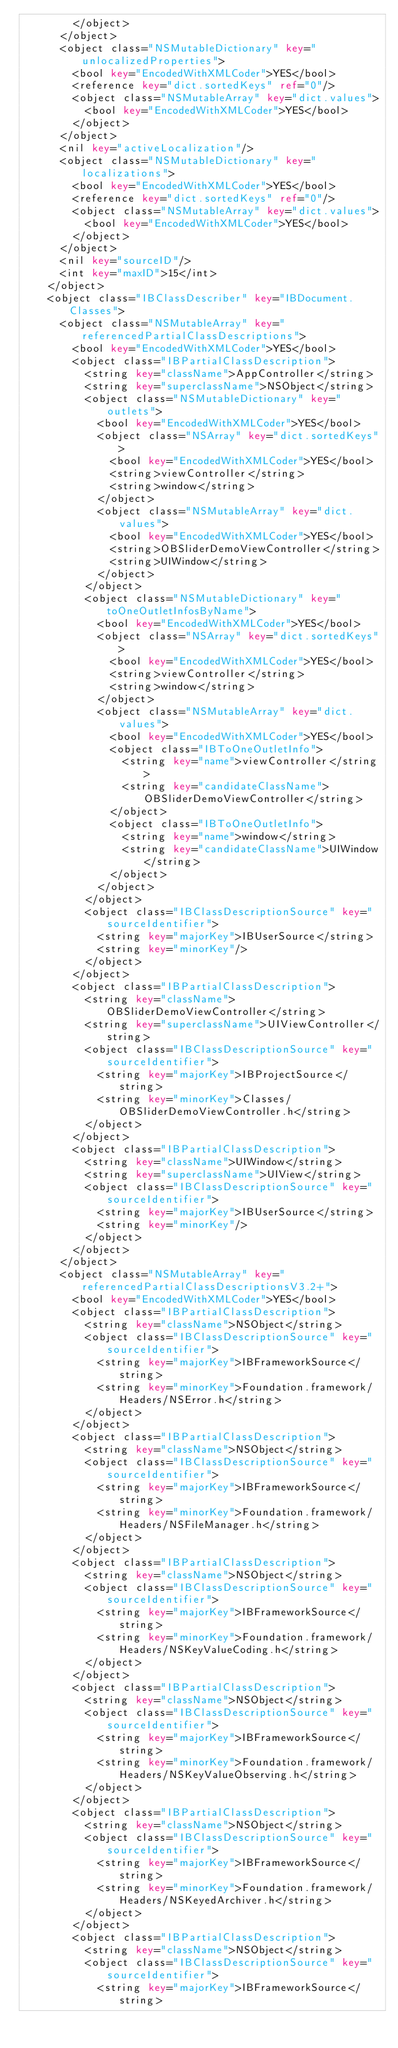Convert code to text. <code><loc_0><loc_0><loc_500><loc_500><_XML_>				</object>
			</object>
			<object class="NSMutableDictionary" key="unlocalizedProperties">
				<bool key="EncodedWithXMLCoder">YES</bool>
				<reference key="dict.sortedKeys" ref="0"/>
				<object class="NSMutableArray" key="dict.values">
					<bool key="EncodedWithXMLCoder">YES</bool>
				</object>
			</object>
			<nil key="activeLocalization"/>
			<object class="NSMutableDictionary" key="localizations">
				<bool key="EncodedWithXMLCoder">YES</bool>
				<reference key="dict.sortedKeys" ref="0"/>
				<object class="NSMutableArray" key="dict.values">
					<bool key="EncodedWithXMLCoder">YES</bool>
				</object>
			</object>
			<nil key="sourceID"/>
			<int key="maxID">15</int>
		</object>
		<object class="IBClassDescriber" key="IBDocument.Classes">
			<object class="NSMutableArray" key="referencedPartialClassDescriptions">
				<bool key="EncodedWithXMLCoder">YES</bool>
				<object class="IBPartialClassDescription">
					<string key="className">AppController</string>
					<string key="superclassName">NSObject</string>
					<object class="NSMutableDictionary" key="outlets">
						<bool key="EncodedWithXMLCoder">YES</bool>
						<object class="NSArray" key="dict.sortedKeys">
							<bool key="EncodedWithXMLCoder">YES</bool>
							<string>viewController</string>
							<string>window</string>
						</object>
						<object class="NSMutableArray" key="dict.values">
							<bool key="EncodedWithXMLCoder">YES</bool>
							<string>OBSliderDemoViewController</string>
							<string>UIWindow</string>
						</object>
					</object>
					<object class="NSMutableDictionary" key="toOneOutletInfosByName">
						<bool key="EncodedWithXMLCoder">YES</bool>
						<object class="NSArray" key="dict.sortedKeys">
							<bool key="EncodedWithXMLCoder">YES</bool>
							<string>viewController</string>
							<string>window</string>
						</object>
						<object class="NSMutableArray" key="dict.values">
							<bool key="EncodedWithXMLCoder">YES</bool>
							<object class="IBToOneOutletInfo">
								<string key="name">viewController</string>
								<string key="candidateClassName">OBSliderDemoViewController</string>
							</object>
							<object class="IBToOneOutletInfo">
								<string key="name">window</string>
								<string key="candidateClassName">UIWindow</string>
							</object>
						</object>
					</object>
					<object class="IBClassDescriptionSource" key="sourceIdentifier">
						<string key="majorKey">IBUserSource</string>
						<string key="minorKey"/>
					</object>
				</object>
				<object class="IBPartialClassDescription">
					<string key="className">OBSliderDemoViewController</string>
					<string key="superclassName">UIViewController</string>
					<object class="IBClassDescriptionSource" key="sourceIdentifier">
						<string key="majorKey">IBProjectSource</string>
						<string key="minorKey">Classes/OBSliderDemoViewController.h</string>
					</object>
				</object>
				<object class="IBPartialClassDescription">
					<string key="className">UIWindow</string>
					<string key="superclassName">UIView</string>
					<object class="IBClassDescriptionSource" key="sourceIdentifier">
						<string key="majorKey">IBUserSource</string>
						<string key="minorKey"/>
					</object>
				</object>
			</object>
			<object class="NSMutableArray" key="referencedPartialClassDescriptionsV3.2+">
				<bool key="EncodedWithXMLCoder">YES</bool>
				<object class="IBPartialClassDescription">
					<string key="className">NSObject</string>
					<object class="IBClassDescriptionSource" key="sourceIdentifier">
						<string key="majorKey">IBFrameworkSource</string>
						<string key="minorKey">Foundation.framework/Headers/NSError.h</string>
					</object>
				</object>
				<object class="IBPartialClassDescription">
					<string key="className">NSObject</string>
					<object class="IBClassDescriptionSource" key="sourceIdentifier">
						<string key="majorKey">IBFrameworkSource</string>
						<string key="minorKey">Foundation.framework/Headers/NSFileManager.h</string>
					</object>
				</object>
				<object class="IBPartialClassDescription">
					<string key="className">NSObject</string>
					<object class="IBClassDescriptionSource" key="sourceIdentifier">
						<string key="majorKey">IBFrameworkSource</string>
						<string key="minorKey">Foundation.framework/Headers/NSKeyValueCoding.h</string>
					</object>
				</object>
				<object class="IBPartialClassDescription">
					<string key="className">NSObject</string>
					<object class="IBClassDescriptionSource" key="sourceIdentifier">
						<string key="majorKey">IBFrameworkSource</string>
						<string key="minorKey">Foundation.framework/Headers/NSKeyValueObserving.h</string>
					</object>
				</object>
				<object class="IBPartialClassDescription">
					<string key="className">NSObject</string>
					<object class="IBClassDescriptionSource" key="sourceIdentifier">
						<string key="majorKey">IBFrameworkSource</string>
						<string key="minorKey">Foundation.framework/Headers/NSKeyedArchiver.h</string>
					</object>
				</object>
				<object class="IBPartialClassDescription">
					<string key="className">NSObject</string>
					<object class="IBClassDescriptionSource" key="sourceIdentifier">
						<string key="majorKey">IBFrameworkSource</string></code> 